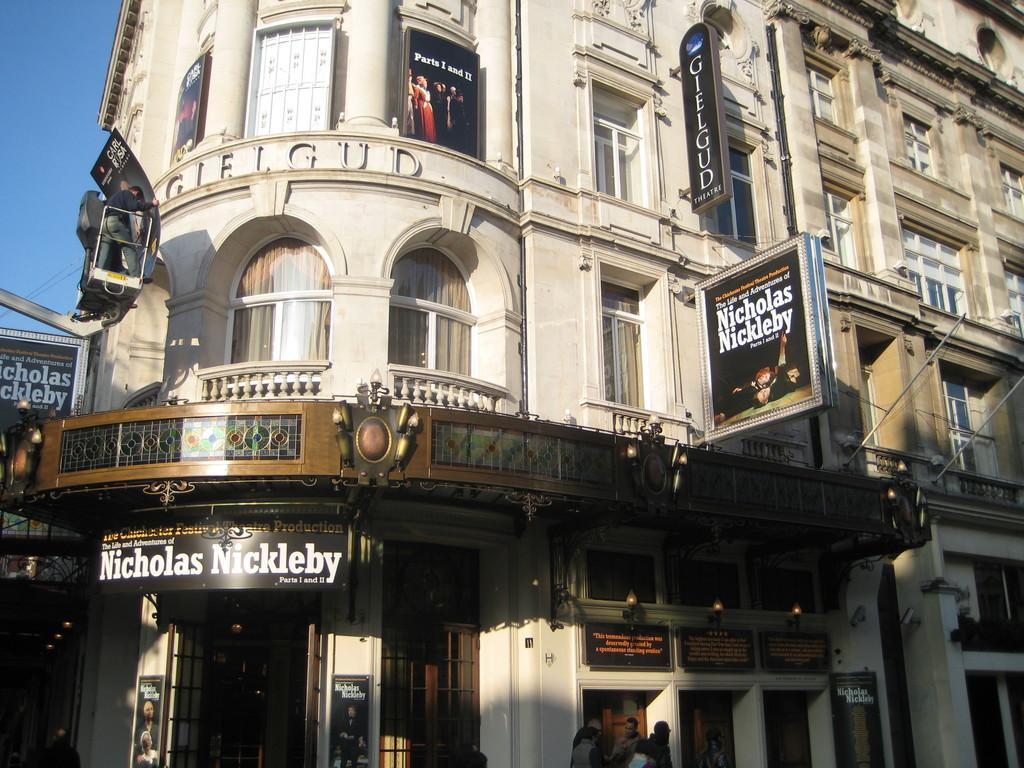What type of structure is present in the image? There is a building in the image. What feature can be seen on the building? The building has windows. What objects are present in the image besides the building? There are boards and people visible in the image. What can be seen in the background of the image? The sky is visible in the background of the image. What type of sock is being used to play songs on the cord in the image? There is no sock, songs, or cord present in the image. 